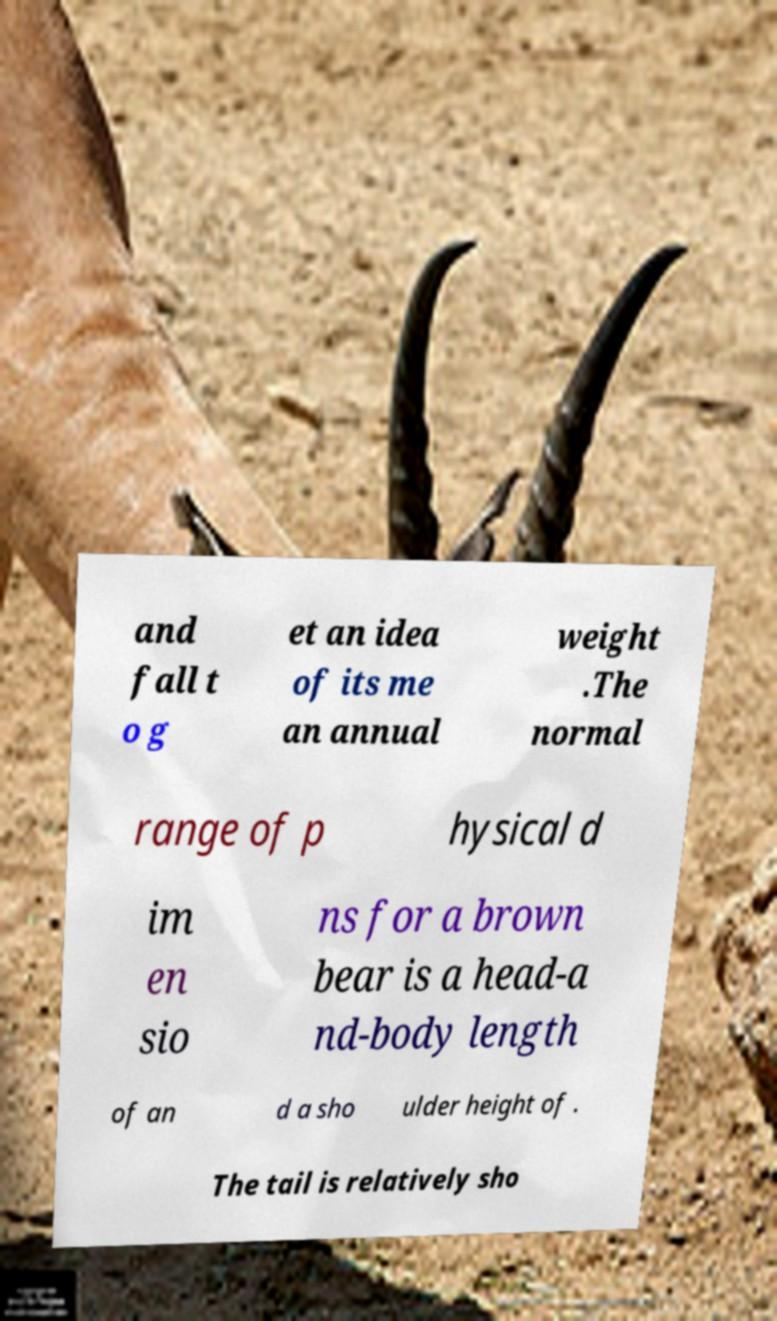There's text embedded in this image that I need extracted. Can you transcribe it verbatim? and fall t o g et an idea of its me an annual weight .The normal range of p hysical d im en sio ns for a brown bear is a head-a nd-body length of an d a sho ulder height of . The tail is relatively sho 